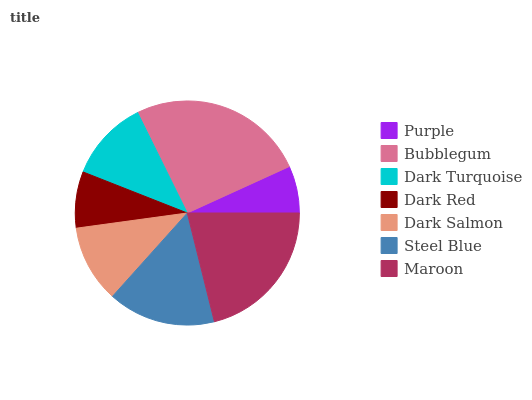Is Purple the minimum?
Answer yes or no. Yes. Is Bubblegum the maximum?
Answer yes or no. Yes. Is Dark Turquoise the minimum?
Answer yes or no. No. Is Dark Turquoise the maximum?
Answer yes or no. No. Is Bubblegum greater than Dark Turquoise?
Answer yes or no. Yes. Is Dark Turquoise less than Bubblegum?
Answer yes or no. Yes. Is Dark Turquoise greater than Bubblegum?
Answer yes or no. No. Is Bubblegum less than Dark Turquoise?
Answer yes or no. No. Is Dark Turquoise the high median?
Answer yes or no. Yes. Is Dark Turquoise the low median?
Answer yes or no. Yes. Is Dark Red the high median?
Answer yes or no. No. Is Purple the low median?
Answer yes or no. No. 